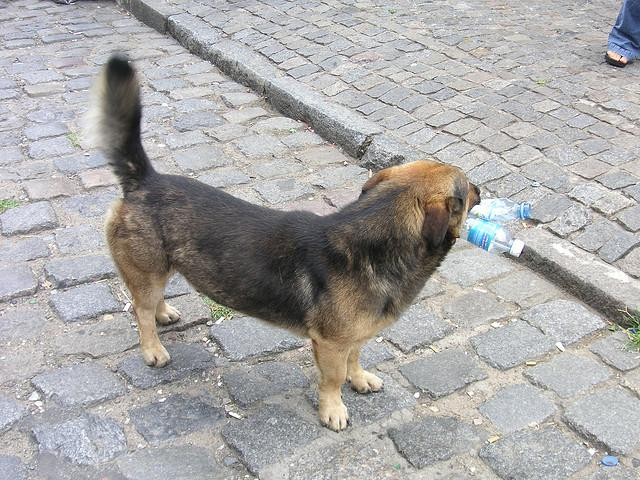What is in the dog's mouth?

Choices:
A) nothing
B) bone
C) 2 bottles
D) water bottle nothing 